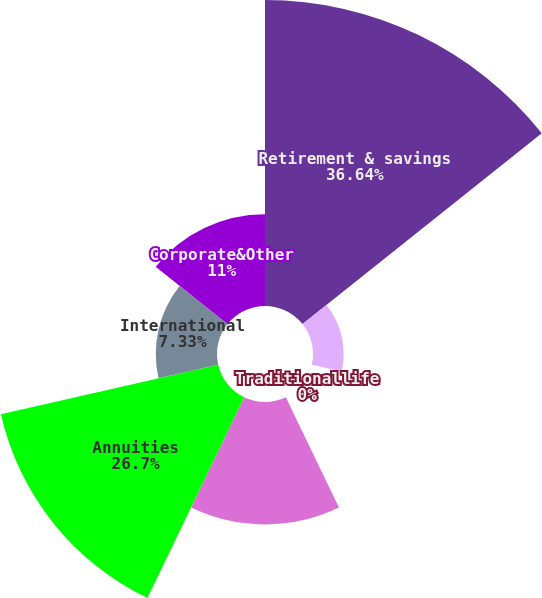Convert chart. <chart><loc_0><loc_0><loc_500><loc_500><pie_chart><fcel>Retirement & savings<fcel>Non-medical health & other<fcel>Traditionallife<fcel>Variable & universal life<fcel>Annuities<fcel>International<fcel>Corporate&Other<nl><fcel>36.65%<fcel>3.67%<fcel>0.0%<fcel>14.66%<fcel>26.7%<fcel>7.33%<fcel>11.0%<nl></chart> 